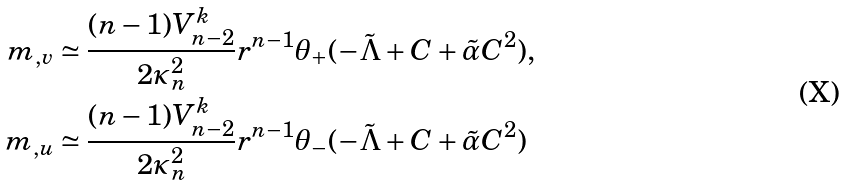Convert formula to latex. <formula><loc_0><loc_0><loc_500><loc_500>m _ { , v } & \simeq \frac { ( n - 1 ) V _ { n - 2 } ^ { k } } { 2 \kappa _ { n } ^ { 2 } } r ^ { n - 1 } \theta _ { + } ( - { \tilde { \Lambda } } + C + { \tilde { \alpha } } C ^ { 2 } ) , \\ m _ { , u } & \simeq \frac { ( n - 1 ) V _ { n - 2 } ^ { k } } { 2 \kappa _ { n } ^ { 2 } } r ^ { n - 1 } \theta _ { - } ( - { \tilde { \Lambda } } + C + { \tilde { \alpha } } C ^ { 2 } )</formula> 